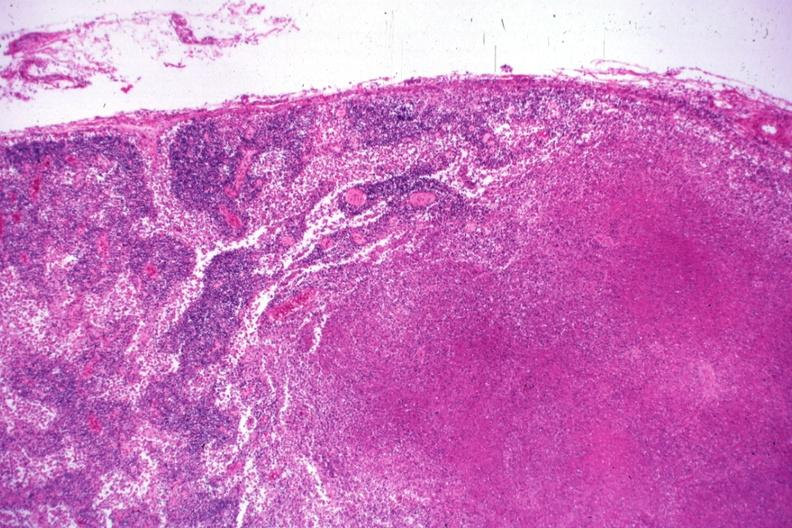s tuberculosis present?
Answer the question using a single word or phrase. Yes 